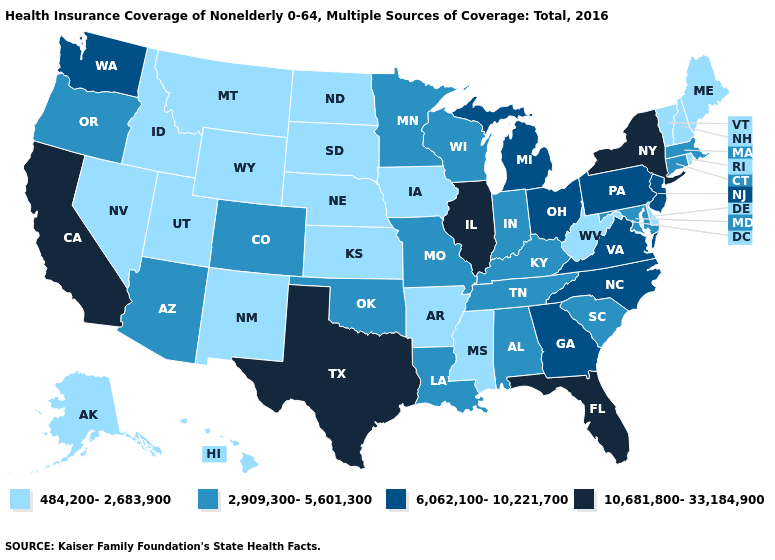Name the states that have a value in the range 484,200-2,683,900?
Write a very short answer. Alaska, Arkansas, Delaware, Hawaii, Idaho, Iowa, Kansas, Maine, Mississippi, Montana, Nebraska, Nevada, New Hampshire, New Mexico, North Dakota, Rhode Island, South Dakota, Utah, Vermont, West Virginia, Wyoming. Among the states that border Michigan , does Ohio have the highest value?
Concise answer only. Yes. Which states have the lowest value in the USA?
Quick response, please. Alaska, Arkansas, Delaware, Hawaii, Idaho, Iowa, Kansas, Maine, Mississippi, Montana, Nebraska, Nevada, New Hampshire, New Mexico, North Dakota, Rhode Island, South Dakota, Utah, Vermont, West Virginia, Wyoming. Name the states that have a value in the range 484,200-2,683,900?
Keep it brief. Alaska, Arkansas, Delaware, Hawaii, Idaho, Iowa, Kansas, Maine, Mississippi, Montana, Nebraska, Nevada, New Hampshire, New Mexico, North Dakota, Rhode Island, South Dakota, Utah, Vermont, West Virginia, Wyoming. Name the states that have a value in the range 2,909,300-5,601,300?
Give a very brief answer. Alabama, Arizona, Colorado, Connecticut, Indiana, Kentucky, Louisiana, Maryland, Massachusetts, Minnesota, Missouri, Oklahoma, Oregon, South Carolina, Tennessee, Wisconsin. What is the highest value in states that border Vermont?
Concise answer only. 10,681,800-33,184,900. Name the states that have a value in the range 6,062,100-10,221,700?
Concise answer only. Georgia, Michigan, New Jersey, North Carolina, Ohio, Pennsylvania, Virginia, Washington. What is the value of Vermont?
Write a very short answer. 484,200-2,683,900. What is the value of Kansas?
Be succinct. 484,200-2,683,900. Name the states that have a value in the range 2,909,300-5,601,300?
Be succinct. Alabama, Arizona, Colorado, Connecticut, Indiana, Kentucky, Louisiana, Maryland, Massachusetts, Minnesota, Missouri, Oklahoma, Oregon, South Carolina, Tennessee, Wisconsin. What is the value of Alaska?
Answer briefly. 484,200-2,683,900. Does Nevada have the same value as Nebraska?
Keep it brief. Yes. Does South Dakota have a lower value than California?
Short answer required. Yes. Which states hav the highest value in the MidWest?
Answer briefly. Illinois. Which states have the highest value in the USA?
Short answer required. California, Florida, Illinois, New York, Texas. 